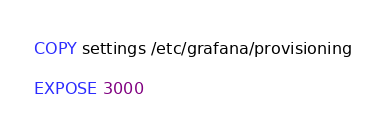<code> <loc_0><loc_0><loc_500><loc_500><_Dockerfile_>
COPY settings /etc/grafana/provisioning

EXPOSE 3000
</code> 